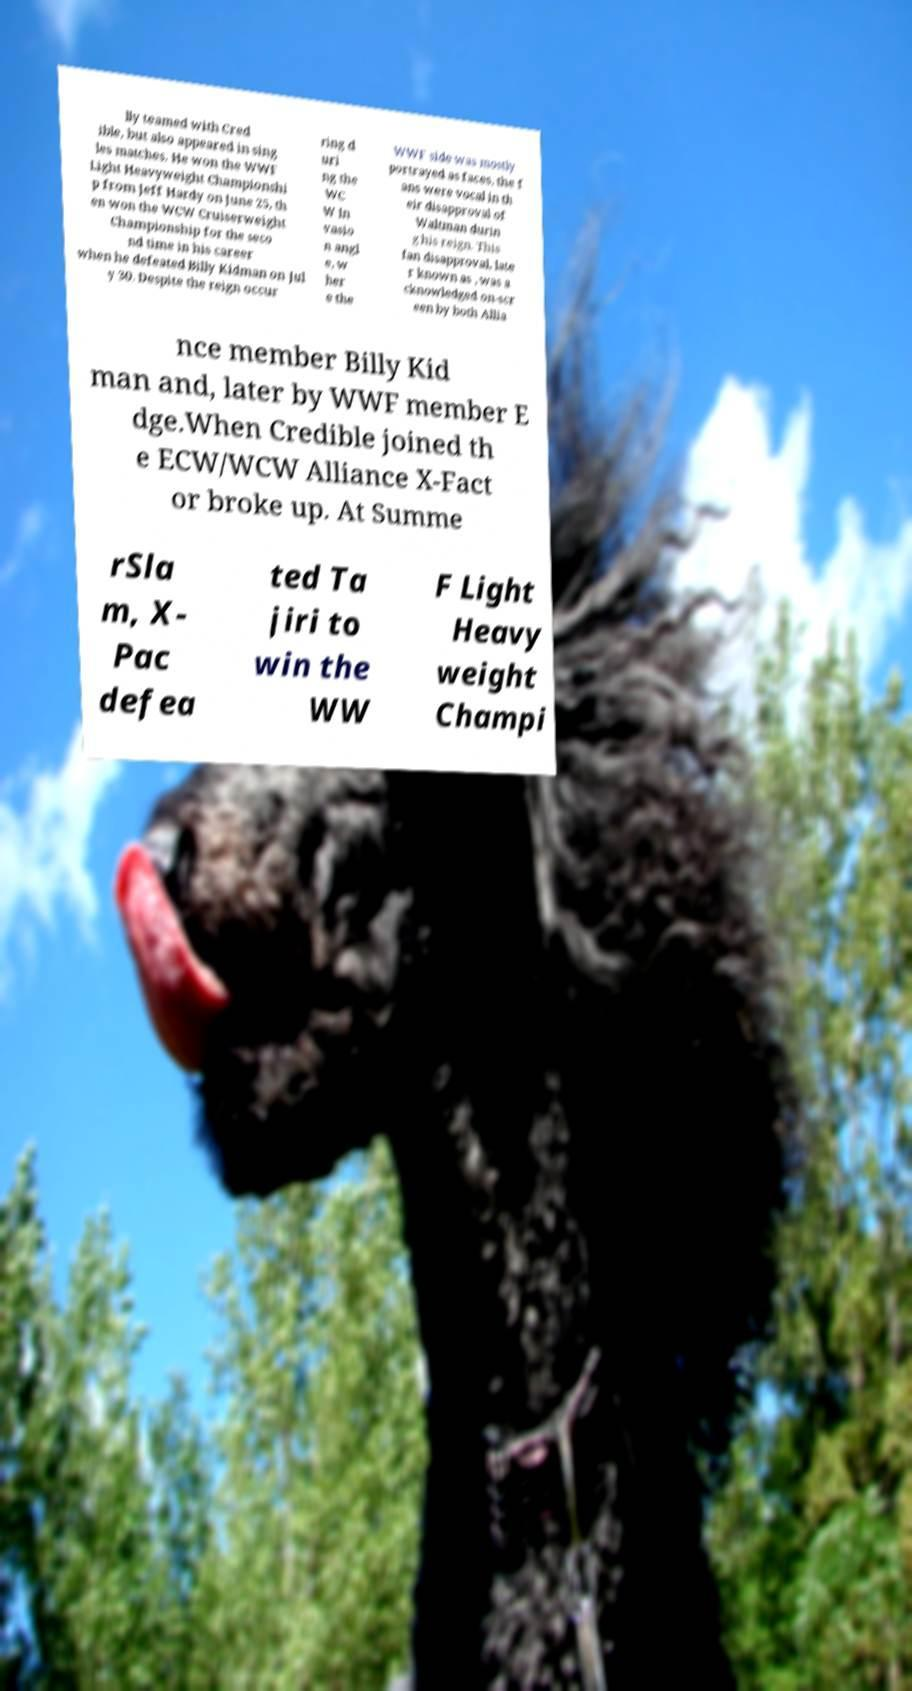There's text embedded in this image that I need extracted. Can you transcribe it verbatim? lly teamed with Cred ible, but also appeared in sing les matches. He won the WWF Light Heavyweight Championshi p from Jeff Hardy on June 25, th en won the WCW Cruiserweight Championship for the seco nd time in his career when he defeated Billy Kidman on Jul y 30. Despite the reign occur ring d uri ng the WC W In vasio n angl e, w her e the WWF side was mostly portrayed as faces, the f ans were vocal in th eir disapproval of Waltman durin g his reign. This fan disapproval, late r known as , was a cknowledged on-scr een by both Allia nce member Billy Kid man and, later by WWF member E dge.When Credible joined th e ECW/WCW Alliance X-Fact or broke up. At Summe rSla m, X- Pac defea ted Ta jiri to win the WW F Light Heavy weight Champi 